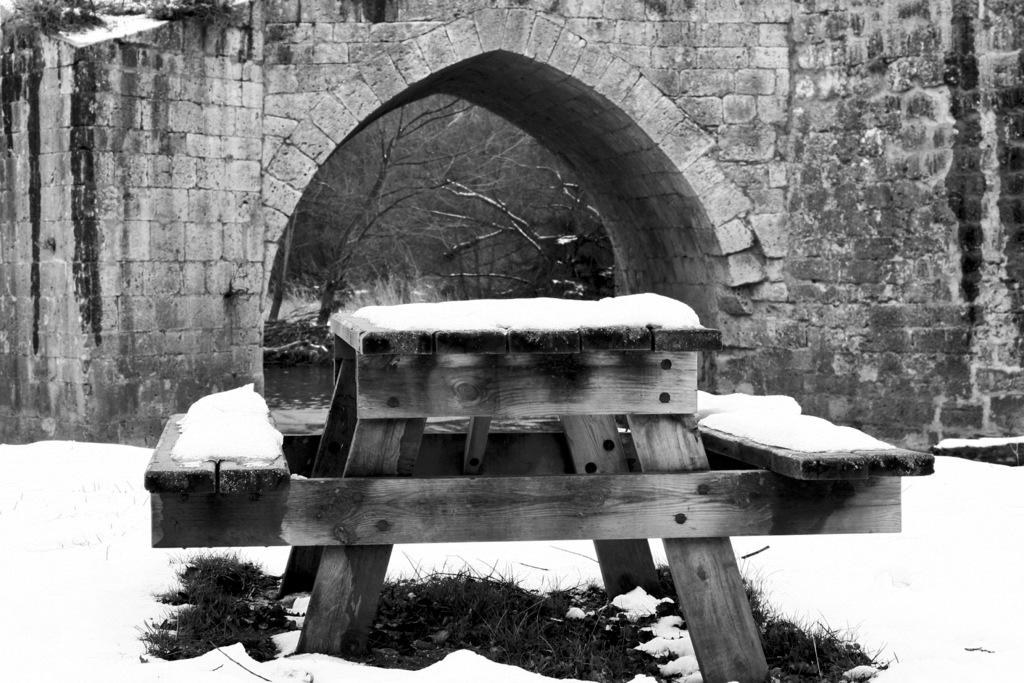What is the color scheme of the image? The image is black and white. What type of seating is present in the image? There is a bench in the image. What is the weather like in the image? There is snow in the image, indicating a cold and likely wintery scene. What can be seen in the background of the image? Trees and water are visible in the background of the image. What architectural feature is present in the image? There is an arch in the image. Can you see a plane flying over the arch in the image? There is no plane visible in the image; it only features a bench, snow, trees, water, and an arch. Are there any friends sitting on the bench in the image? There is no indication of friends or any people sitting on the bench in the image. 